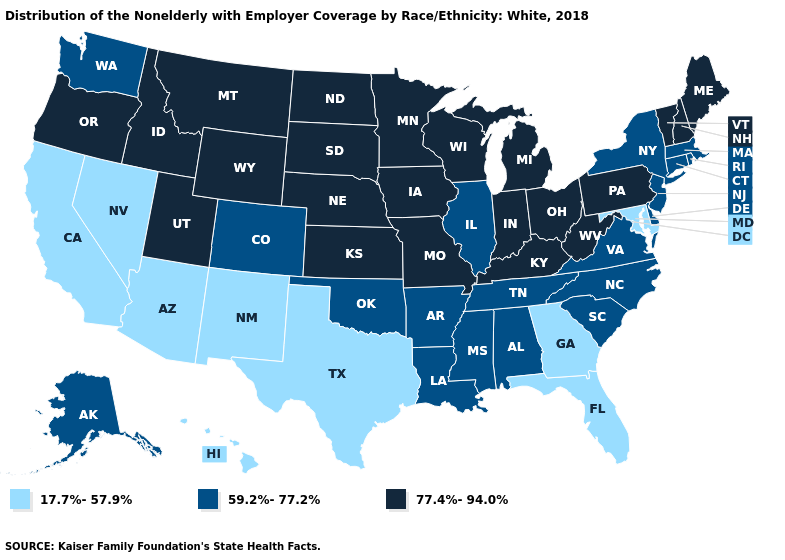What is the value of Nevada?
Short answer required. 17.7%-57.9%. Does Vermont have the highest value in the USA?
Keep it brief. Yes. Is the legend a continuous bar?
Answer briefly. No. Name the states that have a value in the range 77.4%-94.0%?
Write a very short answer. Idaho, Indiana, Iowa, Kansas, Kentucky, Maine, Michigan, Minnesota, Missouri, Montana, Nebraska, New Hampshire, North Dakota, Ohio, Oregon, Pennsylvania, South Dakota, Utah, Vermont, West Virginia, Wisconsin, Wyoming. What is the value of Georgia?
Short answer required. 17.7%-57.9%. Does Pennsylvania have the highest value in the USA?
Short answer required. Yes. Does Nevada have the lowest value in the USA?
Concise answer only. Yes. What is the highest value in the USA?
Keep it brief. 77.4%-94.0%. Among the states that border Connecticut , which have the highest value?
Short answer required. Massachusetts, New York, Rhode Island. What is the lowest value in the MidWest?
Write a very short answer. 59.2%-77.2%. Does the first symbol in the legend represent the smallest category?
Short answer required. Yes. Does Wisconsin have the lowest value in the MidWest?
Keep it brief. No. Does New York have a higher value than Alaska?
Write a very short answer. No. Does Utah have the same value as Louisiana?
Keep it brief. No. 